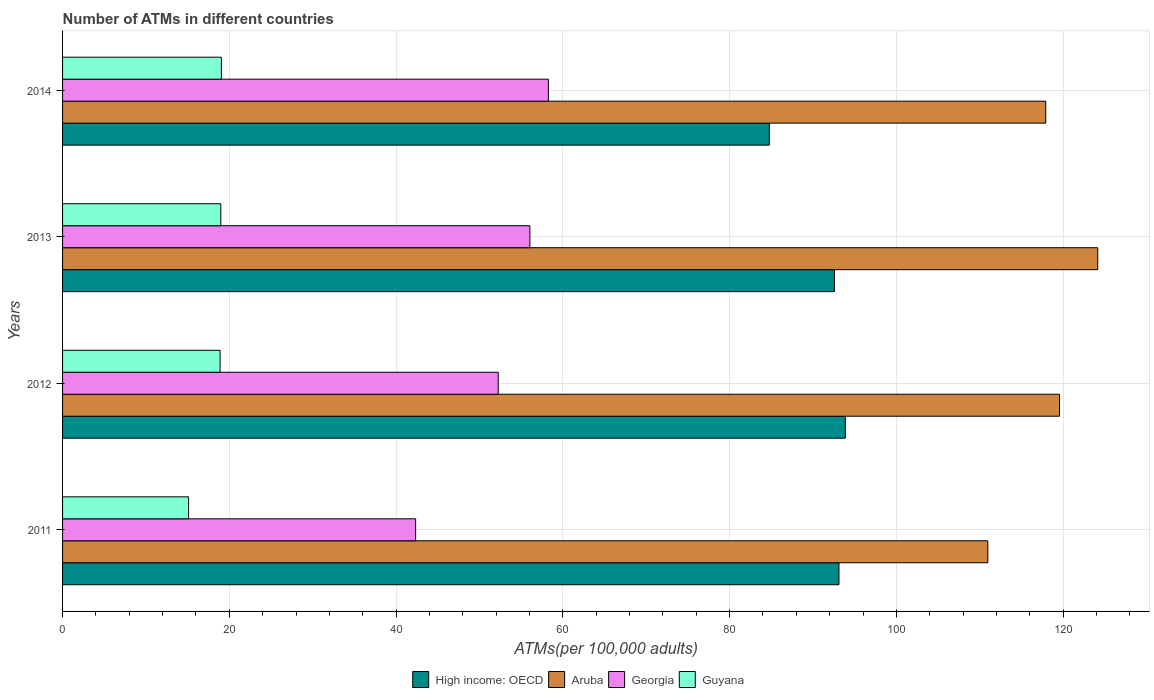How many different coloured bars are there?
Make the answer very short. 4. How many groups of bars are there?
Your response must be concise. 4. What is the label of the 3rd group of bars from the top?
Make the answer very short. 2012. In how many cases, is the number of bars for a given year not equal to the number of legend labels?
Make the answer very short. 0. What is the number of ATMs in Guyana in 2012?
Offer a very short reply. 18.89. Across all years, what is the maximum number of ATMs in Aruba?
Provide a short and direct response. 124.15. Across all years, what is the minimum number of ATMs in High income: OECD?
Provide a succinct answer. 84.77. In which year was the number of ATMs in Aruba maximum?
Provide a succinct answer. 2013. In which year was the number of ATMs in Georgia minimum?
Your answer should be very brief. 2011. What is the total number of ATMs in Guyana in the graph?
Provide a short and direct response. 72.03. What is the difference between the number of ATMs in High income: OECD in 2013 and that in 2014?
Keep it short and to the point. 7.81. What is the difference between the number of ATMs in Guyana in 2011 and the number of ATMs in Georgia in 2014?
Offer a very short reply. -43.15. What is the average number of ATMs in Aruba per year?
Your answer should be very brief. 118.15. In the year 2014, what is the difference between the number of ATMs in High income: OECD and number of ATMs in Aruba?
Offer a very short reply. -33.15. What is the ratio of the number of ATMs in Georgia in 2011 to that in 2014?
Offer a very short reply. 0.73. Is the difference between the number of ATMs in High income: OECD in 2011 and 2012 greater than the difference between the number of ATMs in Aruba in 2011 and 2012?
Offer a terse response. Yes. What is the difference between the highest and the second highest number of ATMs in High income: OECD?
Make the answer very short. 0.77. What is the difference between the highest and the lowest number of ATMs in High income: OECD?
Ensure brevity in your answer.  9.12. In how many years, is the number of ATMs in Guyana greater than the average number of ATMs in Guyana taken over all years?
Your response must be concise. 3. Is it the case that in every year, the sum of the number of ATMs in High income: OECD and number of ATMs in Aruba is greater than the sum of number of ATMs in Georgia and number of ATMs in Guyana?
Make the answer very short. No. What does the 2nd bar from the top in 2012 represents?
Provide a succinct answer. Georgia. What does the 1st bar from the bottom in 2012 represents?
Your answer should be compact. High income: OECD. How many bars are there?
Offer a terse response. 16. How many years are there in the graph?
Your answer should be compact. 4. Are the values on the major ticks of X-axis written in scientific E-notation?
Provide a succinct answer. No. Does the graph contain any zero values?
Make the answer very short. No. Does the graph contain grids?
Ensure brevity in your answer.  Yes. Where does the legend appear in the graph?
Provide a succinct answer. Bottom center. How many legend labels are there?
Give a very brief answer. 4. How are the legend labels stacked?
Provide a short and direct response. Horizontal. What is the title of the graph?
Your answer should be compact. Number of ATMs in different countries. What is the label or title of the X-axis?
Your response must be concise. ATMs(per 100,0 adults). What is the ATMs(per 100,000 adults) of High income: OECD in 2011?
Your answer should be compact. 93.12. What is the ATMs(per 100,000 adults) of Aruba in 2011?
Offer a very short reply. 110.97. What is the ATMs(per 100,000 adults) of Georgia in 2011?
Your answer should be very brief. 42.35. What is the ATMs(per 100,000 adults) in Guyana in 2011?
Give a very brief answer. 15.12. What is the ATMs(per 100,000 adults) in High income: OECD in 2012?
Offer a terse response. 93.88. What is the ATMs(per 100,000 adults) in Aruba in 2012?
Give a very brief answer. 119.57. What is the ATMs(per 100,000 adults) of Georgia in 2012?
Your answer should be very brief. 52.25. What is the ATMs(per 100,000 adults) in Guyana in 2012?
Offer a very short reply. 18.89. What is the ATMs(per 100,000 adults) in High income: OECD in 2013?
Offer a very short reply. 92.57. What is the ATMs(per 100,000 adults) of Aruba in 2013?
Your response must be concise. 124.15. What is the ATMs(per 100,000 adults) in Georgia in 2013?
Your answer should be very brief. 56.05. What is the ATMs(per 100,000 adults) of Guyana in 2013?
Offer a very short reply. 18.98. What is the ATMs(per 100,000 adults) of High income: OECD in 2014?
Your response must be concise. 84.77. What is the ATMs(per 100,000 adults) of Aruba in 2014?
Keep it short and to the point. 117.92. What is the ATMs(per 100,000 adults) of Georgia in 2014?
Your answer should be compact. 58.27. What is the ATMs(per 100,000 adults) of Guyana in 2014?
Keep it short and to the point. 19.05. Across all years, what is the maximum ATMs(per 100,000 adults) of High income: OECD?
Offer a very short reply. 93.88. Across all years, what is the maximum ATMs(per 100,000 adults) in Aruba?
Offer a terse response. 124.15. Across all years, what is the maximum ATMs(per 100,000 adults) in Georgia?
Your answer should be compact. 58.27. Across all years, what is the maximum ATMs(per 100,000 adults) in Guyana?
Give a very brief answer. 19.05. Across all years, what is the minimum ATMs(per 100,000 adults) in High income: OECD?
Your response must be concise. 84.77. Across all years, what is the minimum ATMs(per 100,000 adults) in Aruba?
Give a very brief answer. 110.97. Across all years, what is the minimum ATMs(per 100,000 adults) in Georgia?
Offer a terse response. 42.35. Across all years, what is the minimum ATMs(per 100,000 adults) of Guyana?
Keep it short and to the point. 15.12. What is the total ATMs(per 100,000 adults) of High income: OECD in the graph?
Offer a very short reply. 364.34. What is the total ATMs(per 100,000 adults) in Aruba in the graph?
Give a very brief answer. 472.61. What is the total ATMs(per 100,000 adults) of Georgia in the graph?
Your answer should be very brief. 208.91. What is the total ATMs(per 100,000 adults) of Guyana in the graph?
Provide a short and direct response. 72.03. What is the difference between the ATMs(per 100,000 adults) of High income: OECD in 2011 and that in 2012?
Offer a terse response. -0.77. What is the difference between the ATMs(per 100,000 adults) of Aruba in 2011 and that in 2012?
Your answer should be very brief. -8.6. What is the difference between the ATMs(per 100,000 adults) of Georgia in 2011 and that in 2012?
Provide a succinct answer. -9.9. What is the difference between the ATMs(per 100,000 adults) in Guyana in 2011 and that in 2012?
Your answer should be very brief. -3.78. What is the difference between the ATMs(per 100,000 adults) of High income: OECD in 2011 and that in 2013?
Your answer should be compact. 0.54. What is the difference between the ATMs(per 100,000 adults) of Aruba in 2011 and that in 2013?
Keep it short and to the point. -13.18. What is the difference between the ATMs(per 100,000 adults) of Georgia in 2011 and that in 2013?
Your response must be concise. -13.7. What is the difference between the ATMs(per 100,000 adults) in Guyana in 2011 and that in 2013?
Keep it short and to the point. -3.86. What is the difference between the ATMs(per 100,000 adults) of High income: OECD in 2011 and that in 2014?
Offer a terse response. 8.35. What is the difference between the ATMs(per 100,000 adults) of Aruba in 2011 and that in 2014?
Provide a short and direct response. -6.95. What is the difference between the ATMs(per 100,000 adults) in Georgia in 2011 and that in 2014?
Your response must be concise. -15.92. What is the difference between the ATMs(per 100,000 adults) in Guyana in 2011 and that in 2014?
Provide a succinct answer. -3.93. What is the difference between the ATMs(per 100,000 adults) of High income: OECD in 2012 and that in 2013?
Offer a very short reply. 1.31. What is the difference between the ATMs(per 100,000 adults) of Aruba in 2012 and that in 2013?
Make the answer very short. -4.58. What is the difference between the ATMs(per 100,000 adults) in Georgia in 2012 and that in 2013?
Keep it short and to the point. -3.8. What is the difference between the ATMs(per 100,000 adults) of Guyana in 2012 and that in 2013?
Keep it short and to the point. -0.09. What is the difference between the ATMs(per 100,000 adults) in High income: OECD in 2012 and that in 2014?
Your response must be concise. 9.12. What is the difference between the ATMs(per 100,000 adults) in Aruba in 2012 and that in 2014?
Give a very brief answer. 1.65. What is the difference between the ATMs(per 100,000 adults) in Georgia in 2012 and that in 2014?
Ensure brevity in your answer.  -6.02. What is the difference between the ATMs(per 100,000 adults) of Guyana in 2012 and that in 2014?
Your response must be concise. -0.16. What is the difference between the ATMs(per 100,000 adults) in High income: OECD in 2013 and that in 2014?
Your answer should be compact. 7.81. What is the difference between the ATMs(per 100,000 adults) in Aruba in 2013 and that in 2014?
Provide a succinct answer. 6.24. What is the difference between the ATMs(per 100,000 adults) of Georgia in 2013 and that in 2014?
Offer a very short reply. -2.22. What is the difference between the ATMs(per 100,000 adults) in Guyana in 2013 and that in 2014?
Your response must be concise. -0.07. What is the difference between the ATMs(per 100,000 adults) in High income: OECD in 2011 and the ATMs(per 100,000 adults) in Aruba in 2012?
Your answer should be very brief. -26.45. What is the difference between the ATMs(per 100,000 adults) of High income: OECD in 2011 and the ATMs(per 100,000 adults) of Georgia in 2012?
Ensure brevity in your answer.  40.87. What is the difference between the ATMs(per 100,000 adults) in High income: OECD in 2011 and the ATMs(per 100,000 adults) in Guyana in 2012?
Provide a succinct answer. 74.23. What is the difference between the ATMs(per 100,000 adults) in Aruba in 2011 and the ATMs(per 100,000 adults) in Georgia in 2012?
Give a very brief answer. 58.72. What is the difference between the ATMs(per 100,000 adults) of Aruba in 2011 and the ATMs(per 100,000 adults) of Guyana in 2012?
Keep it short and to the point. 92.08. What is the difference between the ATMs(per 100,000 adults) in Georgia in 2011 and the ATMs(per 100,000 adults) in Guyana in 2012?
Your answer should be compact. 23.46. What is the difference between the ATMs(per 100,000 adults) of High income: OECD in 2011 and the ATMs(per 100,000 adults) of Aruba in 2013?
Provide a succinct answer. -31.04. What is the difference between the ATMs(per 100,000 adults) in High income: OECD in 2011 and the ATMs(per 100,000 adults) in Georgia in 2013?
Provide a succinct answer. 37.07. What is the difference between the ATMs(per 100,000 adults) of High income: OECD in 2011 and the ATMs(per 100,000 adults) of Guyana in 2013?
Ensure brevity in your answer.  74.14. What is the difference between the ATMs(per 100,000 adults) in Aruba in 2011 and the ATMs(per 100,000 adults) in Georgia in 2013?
Offer a very short reply. 54.92. What is the difference between the ATMs(per 100,000 adults) of Aruba in 2011 and the ATMs(per 100,000 adults) of Guyana in 2013?
Give a very brief answer. 91.99. What is the difference between the ATMs(per 100,000 adults) of Georgia in 2011 and the ATMs(per 100,000 adults) of Guyana in 2013?
Give a very brief answer. 23.37. What is the difference between the ATMs(per 100,000 adults) of High income: OECD in 2011 and the ATMs(per 100,000 adults) of Aruba in 2014?
Your response must be concise. -24.8. What is the difference between the ATMs(per 100,000 adults) of High income: OECD in 2011 and the ATMs(per 100,000 adults) of Georgia in 2014?
Your answer should be very brief. 34.85. What is the difference between the ATMs(per 100,000 adults) in High income: OECD in 2011 and the ATMs(per 100,000 adults) in Guyana in 2014?
Your answer should be compact. 74.07. What is the difference between the ATMs(per 100,000 adults) in Aruba in 2011 and the ATMs(per 100,000 adults) in Georgia in 2014?
Provide a short and direct response. 52.7. What is the difference between the ATMs(per 100,000 adults) in Aruba in 2011 and the ATMs(per 100,000 adults) in Guyana in 2014?
Provide a succinct answer. 91.92. What is the difference between the ATMs(per 100,000 adults) in Georgia in 2011 and the ATMs(per 100,000 adults) in Guyana in 2014?
Your answer should be compact. 23.3. What is the difference between the ATMs(per 100,000 adults) in High income: OECD in 2012 and the ATMs(per 100,000 adults) in Aruba in 2013?
Offer a terse response. -30.27. What is the difference between the ATMs(per 100,000 adults) of High income: OECD in 2012 and the ATMs(per 100,000 adults) of Georgia in 2013?
Offer a very short reply. 37.84. What is the difference between the ATMs(per 100,000 adults) of High income: OECD in 2012 and the ATMs(per 100,000 adults) of Guyana in 2013?
Your answer should be very brief. 74.91. What is the difference between the ATMs(per 100,000 adults) in Aruba in 2012 and the ATMs(per 100,000 adults) in Georgia in 2013?
Keep it short and to the point. 63.52. What is the difference between the ATMs(per 100,000 adults) of Aruba in 2012 and the ATMs(per 100,000 adults) of Guyana in 2013?
Offer a very short reply. 100.59. What is the difference between the ATMs(per 100,000 adults) in Georgia in 2012 and the ATMs(per 100,000 adults) in Guyana in 2013?
Provide a short and direct response. 33.27. What is the difference between the ATMs(per 100,000 adults) in High income: OECD in 2012 and the ATMs(per 100,000 adults) in Aruba in 2014?
Provide a short and direct response. -24.03. What is the difference between the ATMs(per 100,000 adults) of High income: OECD in 2012 and the ATMs(per 100,000 adults) of Georgia in 2014?
Make the answer very short. 35.62. What is the difference between the ATMs(per 100,000 adults) of High income: OECD in 2012 and the ATMs(per 100,000 adults) of Guyana in 2014?
Keep it short and to the point. 74.84. What is the difference between the ATMs(per 100,000 adults) of Aruba in 2012 and the ATMs(per 100,000 adults) of Georgia in 2014?
Offer a very short reply. 61.3. What is the difference between the ATMs(per 100,000 adults) of Aruba in 2012 and the ATMs(per 100,000 adults) of Guyana in 2014?
Your answer should be very brief. 100.52. What is the difference between the ATMs(per 100,000 adults) of Georgia in 2012 and the ATMs(per 100,000 adults) of Guyana in 2014?
Keep it short and to the point. 33.2. What is the difference between the ATMs(per 100,000 adults) in High income: OECD in 2013 and the ATMs(per 100,000 adults) in Aruba in 2014?
Provide a short and direct response. -25.34. What is the difference between the ATMs(per 100,000 adults) in High income: OECD in 2013 and the ATMs(per 100,000 adults) in Georgia in 2014?
Keep it short and to the point. 34.31. What is the difference between the ATMs(per 100,000 adults) of High income: OECD in 2013 and the ATMs(per 100,000 adults) of Guyana in 2014?
Keep it short and to the point. 73.53. What is the difference between the ATMs(per 100,000 adults) in Aruba in 2013 and the ATMs(per 100,000 adults) in Georgia in 2014?
Provide a succinct answer. 65.89. What is the difference between the ATMs(per 100,000 adults) of Aruba in 2013 and the ATMs(per 100,000 adults) of Guyana in 2014?
Ensure brevity in your answer.  105.11. What is the difference between the ATMs(per 100,000 adults) in Georgia in 2013 and the ATMs(per 100,000 adults) in Guyana in 2014?
Your answer should be very brief. 37. What is the average ATMs(per 100,000 adults) in High income: OECD per year?
Your answer should be compact. 91.09. What is the average ATMs(per 100,000 adults) of Aruba per year?
Give a very brief answer. 118.15. What is the average ATMs(per 100,000 adults) in Georgia per year?
Give a very brief answer. 52.23. What is the average ATMs(per 100,000 adults) of Guyana per year?
Ensure brevity in your answer.  18.01. In the year 2011, what is the difference between the ATMs(per 100,000 adults) of High income: OECD and ATMs(per 100,000 adults) of Aruba?
Give a very brief answer. -17.85. In the year 2011, what is the difference between the ATMs(per 100,000 adults) of High income: OECD and ATMs(per 100,000 adults) of Georgia?
Offer a very short reply. 50.77. In the year 2011, what is the difference between the ATMs(per 100,000 adults) in High income: OECD and ATMs(per 100,000 adults) in Guyana?
Make the answer very short. 78. In the year 2011, what is the difference between the ATMs(per 100,000 adults) of Aruba and ATMs(per 100,000 adults) of Georgia?
Offer a very short reply. 68.62. In the year 2011, what is the difference between the ATMs(per 100,000 adults) in Aruba and ATMs(per 100,000 adults) in Guyana?
Ensure brevity in your answer.  95.86. In the year 2011, what is the difference between the ATMs(per 100,000 adults) in Georgia and ATMs(per 100,000 adults) in Guyana?
Your answer should be very brief. 27.23. In the year 2012, what is the difference between the ATMs(per 100,000 adults) in High income: OECD and ATMs(per 100,000 adults) in Aruba?
Offer a terse response. -25.69. In the year 2012, what is the difference between the ATMs(per 100,000 adults) in High income: OECD and ATMs(per 100,000 adults) in Georgia?
Provide a short and direct response. 41.63. In the year 2012, what is the difference between the ATMs(per 100,000 adults) of High income: OECD and ATMs(per 100,000 adults) of Guyana?
Offer a terse response. 74.99. In the year 2012, what is the difference between the ATMs(per 100,000 adults) in Aruba and ATMs(per 100,000 adults) in Georgia?
Offer a terse response. 67.32. In the year 2012, what is the difference between the ATMs(per 100,000 adults) in Aruba and ATMs(per 100,000 adults) in Guyana?
Your response must be concise. 100.68. In the year 2012, what is the difference between the ATMs(per 100,000 adults) of Georgia and ATMs(per 100,000 adults) of Guyana?
Ensure brevity in your answer.  33.36. In the year 2013, what is the difference between the ATMs(per 100,000 adults) of High income: OECD and ATMs(per 100,000 adults) of Aruba?
Make the answer very short. -31.58. In the year 2013, what is the difference between the ATMs(per 100,000 adults) in High income: OECD and ATMs(per 100,000 adults) in Georgia?
Ensure brevity in your answer.  36.53. In the year 2013, what is the difference between the ATMs(per 100,000 adults) in High income: OECD and ATMs(per 100,000 adults) in Guyana?
Make the answer very short. 73.6. In the year 2013, what is the difference between the ATMs(per 100,000 adults) of Aruba and ATMs(per 100,000 adults) of Georgia?
Give a very brief answer. 68.11. In the year 2013, what is the difference between the ATMs(per 100,000 adults) in Aruba and ATMs(per 100,000 adults) in Guyana?
Give a very brief answer. 105.17. In the year 2013, what is the difference between the ATMs(per 100,000 adults) in Georgia and ATMs(per 100,000 adults) in Guyana?
Provide a short and direct response. 37.07. In the year 2014, what is the difference between the ATMs(per 100,000 adults) of High income: OECD and ATMs(per 100,000 adults) of Aruba?
Offer a very short reply. -33.15. In the year 2014, what is the difference between the ATMs(per 100,000 adults) of High income: OECD and ATMs(per 100,000 adults) of Georgia?
Provide a short and direct response. 26.5. In the year 2014, what is the difference between the ATMs(per 100,000 adults) in High income: OECD and ATMs(per 100,000 adults) in Guyana?
Make the answer very short. 65.72. In the year 2014, what is the difference between the ATMs(per 100,000 adults) in Aruba and ATMs(per 100,000 adults) in Georgia?
Your answer should be compact. 59.65. In the year 2014, what is the difference between the ATMs(per 100,000 adults) of Aruba and ATMs(per 100,000 adults) of Guyana?
Offer a very short reply. 98.87. In the year 2014, what is the difference between the ATMs(per 100,000 adults) in Georgia and ATMs(per 100,000 adults) in Guyana?
Your response must be concise. 39.22. What is the ratio of the ATMs(per 100,000 adults) of High income: OECD in 2011 to that in 2012?
Ensure brevity in your answer.  0.99. What is the ratio of the ATMs(per 100,000 adults) in Aruba in 2011 to that in 2012?
Offer a very short reply. 0.93. What is the ratio of the ATMs(per 100,000 adults) of Georgia in 2011 to that in 2012?
Give a very brief answer. 0.81. What is the ratio of the ATMs(per 100,000 adults) of Guyana in 2011 to that in 2012?
Provide a succinct answer. 0.8. What is the ratio of the ATMs(per 100,000 adults) of High income: OECD in 2011 to that in 2013?
Your answer should be compact. 1.01. What is the ratio of the ATMs(per 100,000 adults) in Aruba in 2011 to that in 2013?
Provide a short and direct response. 0.89. What is the ratio of the ATMs(per 100,000 adults) of Georgia in 2011 to that in 2013?
Make the answer very short. 0.76. What is the ratio of the ATMs(per 100,000 adults) in Guyana in 2011 to that in 2013?
Your answer should be very brief. 0.8. What is the ratio of the ATMs(per 100,000 adults) of High income: OECD in 2011 to that in 2014?
Your answer should be compact. 1.1. What is the ratio of the ATMs(per 100,000 adults) in Aruba in 2011 to that in 2014?
Offer a very short reply. 0.94. What is the ratio of the ATMs(per 100,000 adults) in Georgia in 2011 to that in 2014?
Your response must be concise. 0.73. What is the ratio of the ATMs(per 100,000 adults) of Guyana in 2011 to that in 2014?
Ensure brevity in your answer.  0.79. What is the ratio of the ATMs(per 100,000 adults) of High income: OECD in 2012 to that in 2013?
Give a very brief answer. 1.01. What is the ratio of the ATMs(per 100,000 adults) in Aruba in 2012 to that in 2013?
Your response must be concise. 0.96. What is the ratio of the ATMs(per 100,000 adults) of Georgia in 2012 to that in 2013?
Offer a very short reply. 0.93. What is the ratio of the ATMs(per 100,000 adults) of High income: OECD in 2012 to that in 2014?
Provide a short and direct response. 1.11. What is the ratio of the ATMs(per 100,000 adults) of Georgia in 2012 to that in 2014?
Ensure brevity in your answer.  0.9. What is the ratio of the ATMs(per 100,000 adults) of High income: OECD in 2013 to that in 2014?
Your response must be concise. 1.09. What is the ratio of the ATMs(per 100,000 adults) in Aruba in 2013 to that in 2014?
Make the answer very short. 1.05. What is the ratio of the ATMs(per 100,000 adults) of Georgia in 2013 to that in 2014?
Make the answer very short. 0.96. What is the ratio of the ATMs(per 100,000 adults) of Guyana in 2013 to that in 2014?
Give a very brief answer. 1. What is the difference between the highest and the second highest ATMs(per 100,000 adults) of High income: OECD?
Your response must be concise. 0.77. What is the difference between the highest and the second highest ATMs(per 100,000 adults) of Aruba?
Provide a short and direct response. 4.58. What is the difference between the highest and the second highest ATMs(per 100,000 adults) of Georgia?
Offer a terse response. 2.22. What is the difference between the highest and the second highest ATMs(per 100,000 adults) in Guyana?
Your answer should be compact. 0.07. What is the difference between the highest and the lowest ATMs(per 100,000 adults) of High income: OECD?
Your answer should be compact. 9.12. What is the difference between the highest and the lowest ATMs(per 100,000 adults) in Aruba?
Your answer should be very brief. 13.18. What is the difference between the highest and the lowest ATMs(per 100,000 adults) of Georgia?
Ensure brevity in your answer.  15.92. What is the difference between the highest and the lowest ATMs(per 100,000 adults) in Guyana?
Offer a terse response. 3.93. 